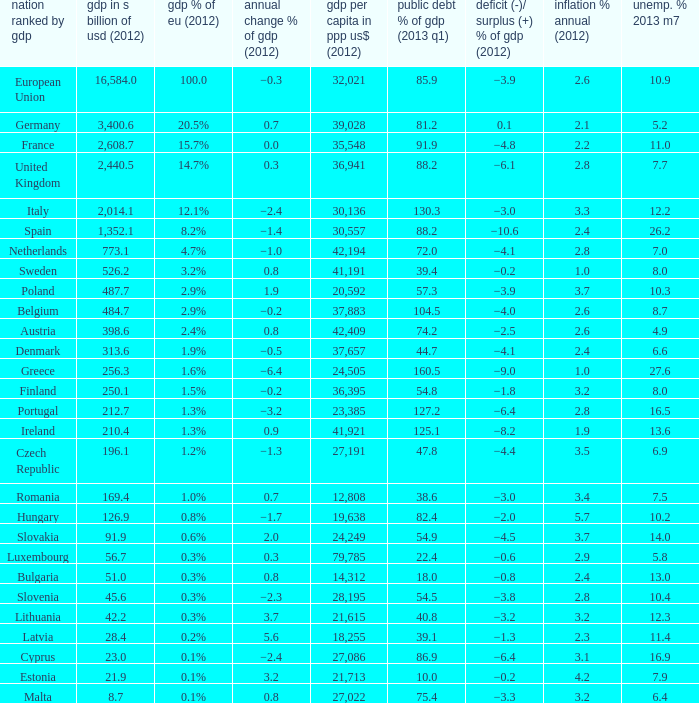What is the GDP % of EU in 2012 of the country with a GDP in billions of USD in 2012 of 256.3? 1.6%. 